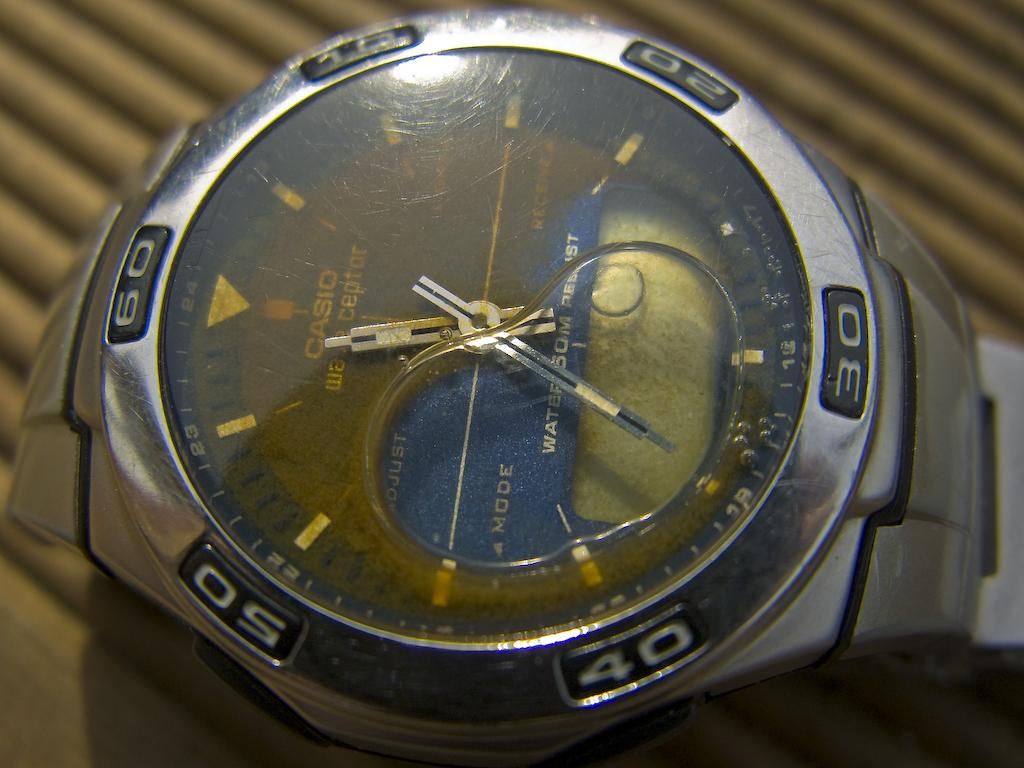Provide a one-sentence caption for the provided image. The water resistant Casio watch apparently was not waterproof. 